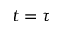Convert formula to latex. <formula><loc_0><loc_0><loc_500><loc_500>t = \tau</formula> 